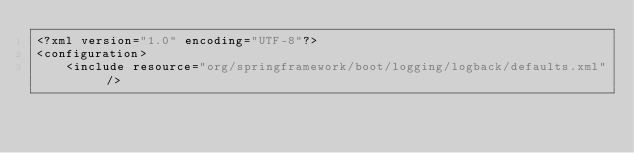<code> <loc_0><loc_0><loc_500><loc_500><_XML_><?xml version="1.0" encoding="UTF-8"?>
<configuration>
    <include resource="org/springframework/boot/logging/logback/defaults.xml" />
</code> 